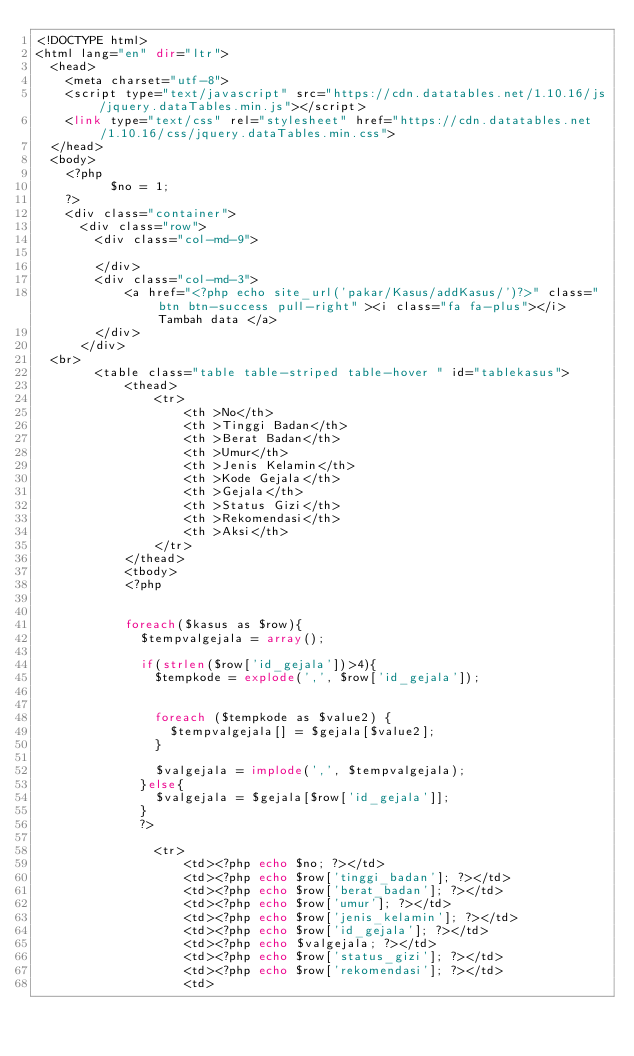<code> <loc_0><loc_0><loc_500><loc_500><_PHP_><!DOCTYPE html>
<html lang="en" dir="ltr">
  <head>
    <meta charset="utf-8">
    <script type="text/javascript" src="https://cdn.datatables.net/1.10.16/js/jquery.dataTables.min.js"></script>
    <link type="text/css" rel="stylesheet" href="https://cdn.datatables.net/1.10.16/css/jquery.dataTables.min.css">
  </head>
  <body>
    <?php
          $no = 1;
    ?>
    <div class="container">
      <div class="row">
        <div class="col-md-9">

        </div>
        <div class="col-md-3">
            <a href="<?php echo site_url('pakar/Kasus/addKasus/')?>" class="btn btn-success pull-right" ><i class="fa fa-plus"></i> Tambah data </a>
        </div>
      </div>
  <br>
        <table class="table table-striped table-hover " id="tablekasus">
            <thead>
                <tr>
                    <th >No</th>
                    <th >Tinggi Badan</th>
                    <th >Berat Badan</th>
                    <th >Umur</th>
                    <th >Jenis Kelamin</th>
                    <th >Kode Gejala</th>
                    <th >Gejala</th>
                    <th >Status Gizi</th>
                    <th >Rekomendasi</th>
                    <th >Aksi</th>
                </tr>
            </thead>
            <tbody>
            <?php 
            

            foreach($kasus as $row){ 
              $tempvalgejala = array();
                
              if(strlen($row['id_gejala'])>4){
                $tempkode = explode(',', $row['id_gejala']);
               

                foreach ($tempkode as $value2) {
                  $tempvalgejala[] = $gejala[$value2];
                }
                
                $valgejala = implode(',', $tempvalgejala);
              }else{
                $valgejala = $gejala[$row['id_gejala']];
              }
              ?>

                <tr>
                    <td><?php echo $no; ?></td>
                    <td><?php echo $row['tinggi_badan']; ?></td>
                    <td><?php echo $row['berat_badan']; ?></td>
                    <td><?php echo $row['umur']; ?></td>
                    <td><?php echo $row['jenis_kelamin']; ?></td>
                    <td><?php echo $row['id_gejala']; ?></td>
                    <td><?php echo $valgejala; ?></td> 
                    <td><?php echo $row['status_gizi']; ?></td>
                    <td><?php echo $row['rekomendasi']; ?></td>
                    <td>
</code> 